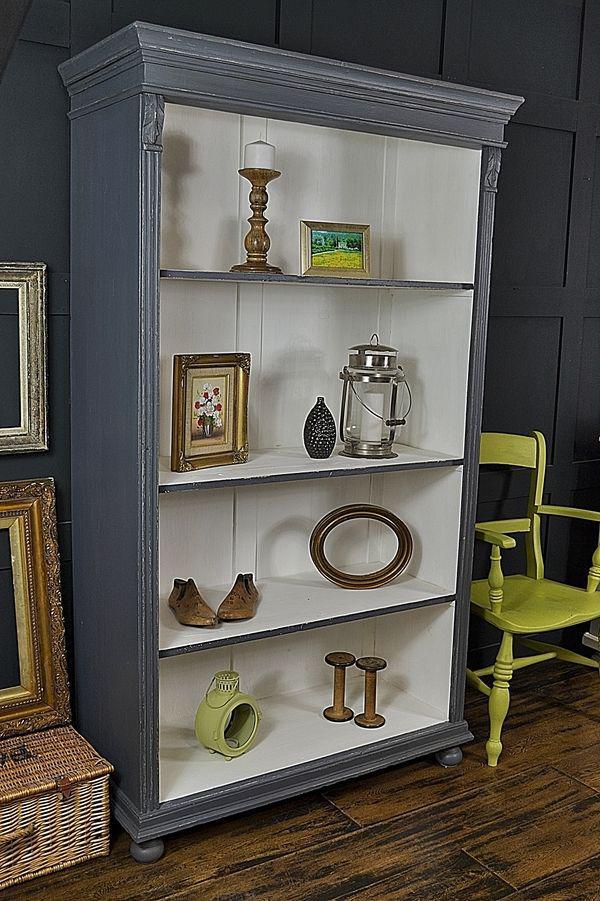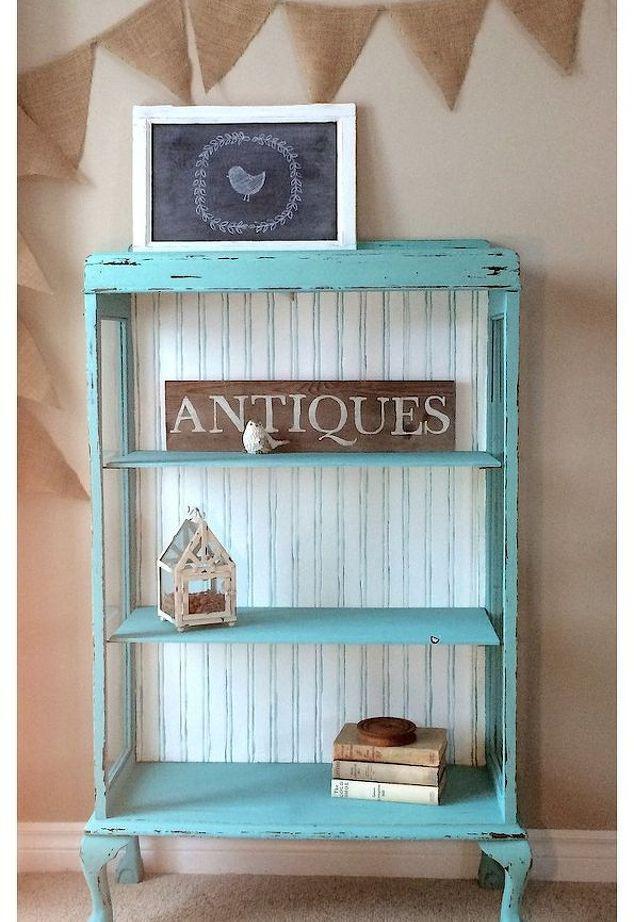The first image is the image on the left, the second image is the image on the right. Examine the images to the left and right. Is the description "At least one shelving unit is teal." accurate? Answer yes or no. Yes. The first image is the image on the left, the second image is the image on the right. Examine the images to the left and right. Is the description "One of the cabinets has doors." accurate? Answer yes or no. No. 